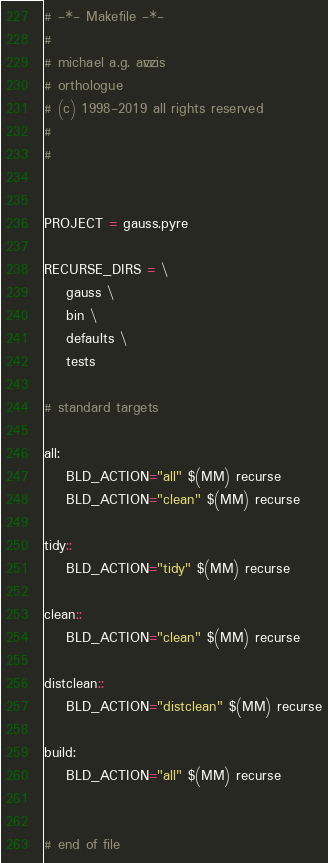<code> <loc_0><loc_0><loc_500><loc_500><_ObjectiveC_># -*- Makefile -*-
#
# michael a.g. aïvázis
# orthologue
# (c) 1998-2019 all rights reserved
#
#


PROJECT = gauss.pyre

RECURSE_DIRS = \
    gauss \
    bin \
    defaults \
    tests

# standard targets

all:
	BLD_ACTION="all" $(MM) recurse
	BLD_ACTION="clean" $(MM) recurse

tidy::
	BLD_ACTION="tidy" $(MM) recurse

clean::
	BLD_ACTION="clean" $(MM) recurse

distclean::
	BLD_ACTION="distclean" $(MM) recurse

build:
	BLD_ACTION="all" $(MM) recurse


# end of file
</code> 